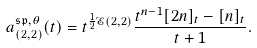<formula> <loc_0><loc_0><loc_500><loc_500>a _ { ( 2 , 2 ) } ^ { \mathfrak { s p } , \theta } ( t ) = t ^ { \frac { 1 } { 2 } \mathcal { E } ( 2 , 2 ) } \frac { t ^ { n - 1 } [ 2 n ] _ { t } - [ n ] _ { t } } { t + 1 } .</formula> 